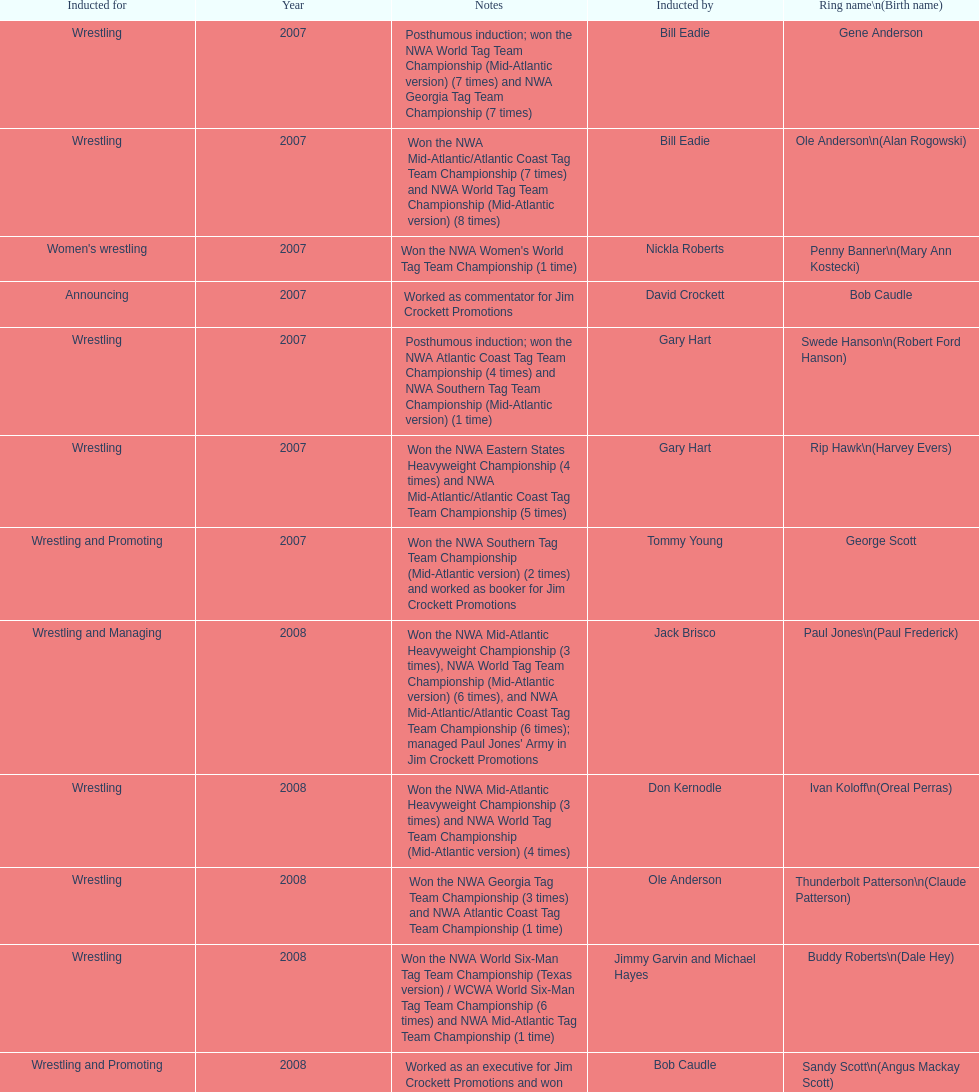How many members were inducted for announcing? 2. Write the full table. {'header': ['Inducted for', 'Year', 'Notes', 'Inducted by', 'Ring name\\n(Birth name)'], 'rows': [['Wrestling', '2007', 'Posthumous induction; won the NWA World Tag Team Championship (Mid-Atlantic version) (7 times) and NWA Georgia Tag Team Championship (7 times)', 'Bill Eadie', 'Gene Anderson'], ['Wrestling', '2007', 'Won the NWA Mid-Atlantic/Atlantic Coast Tag Team Championship (7 times) and NWA World Tag Team Championship (Mid-Atlantic version) (8 times)', 'Bill Eadie', 'Ole Anderson\\n(Alan Rogowski)'], ["Women's wrestling", '2007', "Won the NWA Women's World Tag Team Championship (1 time)", 'Nickla Roberts', 'Penny Banner\\n(Mary Ann Kostecki)'], ['Announcing', '2007', 'Worked as commentator for Jim Crockett Promotions', 'David Crockett', 'Bob Caudle'], ['Wrestling', '2007', 'Posthumous induction; won the NWA Atlantic Coast Tag Team Championship (4 times) and NWA Southern Tag Team Championship (Mid-Atlantic version) (1 time)', 'Gary Hart', 'Swede Hanson\\n(Robert Ford Hanson)'], ['Wrestling', '2007', 'Won the NWA Eastern States Heavyweight Championship (4 times) and NWA Mid-Atlantic/Atlantic Coast Tag Team Championship (5 times)', 'Gary Hart', 'Rip Hawk\\n(Harvey Evers)'], ['Wrestling and Promoting', '2007', 'Won the NWA Southern Tag Team Championship (Mid-Atlantic version) (2 times) and worked as booker for Jim Crockett Promotions', 'Tommy Young', 'George Scott'], ['Wrestling and Managing', '2008', "Won the NWA Mid-Atlantic Heavyweight Championship (3 times), NWA World Tag Team Championship (Mid-Atlantic version) (6 times), and NWA Mid-Atlantic/Atlantic Coast Tag Team Championship (6 times); managed Paul Jones' Army in Jim Crockett Promotions", 'Jack Brisco', 'Paul Jones\\n(Paul Frederick)'], ['Wrestling', '2008', 'Won the NWA Mid-Atlantic Heavyweight Championship (3 times) and NWA World Tag Team Championship (Mid-Atlantic version) (4 times)', 'Don Kernodle', 'Ivan Koloff\\n(Oreal Perras)'], ['Wrestling', '2008', 'Won the NWA Georgia Tag Team Championship (3 times) and NWA Atlantic Coast Tag Team Championship (1 time)', 'Ole Anderson', 'Thunderbolt Patterson\\n(Claude Patterson)'], ['Wrestling', '2008', 'Won the NWA World Six-Man Tag Team Championship (Texas version) / WCWA World Six-Man Tag Team Championship (6 times) and NWA Mid-Atlantic Tag Team Championship (1 time)', 'Jimmy Garvin and Michael Hayes', 'Buddy Roberts\\n(Dale Hey)'], ['Wrestling and Promoting', '2008', 'Worked as an executive for Jim Crockett Promotions and won the NWA World Tag Team Championship (Central States version) (1 time) and NWA Southern Tag Team Championship (Mid-Atlantic version) (3 times)', 'Bob Caudle', 'Sandy Scott\\n(Angus Mackay Scott)'], ['Wrestling', '2008', 'Won the NWA United States Tag Team Championship (Tri-State version) (2 times) and NWA Texas Heavyweight Championship (1 time)', 'Magnum T.A.', 'Grizzly Smith\\n(Aurelian Smith)'], ['Wrestling', '2008', 'Posthumous induction; won the NWA Atlantic Coast/Mid-Atlantic Tag Team Championship (8 times) and NWA Southern Tag Team Championship (Mid-Atlantic version) (6 times)', 'Rip Hawk', 'Johnny Weaver\\n(Kenneth Eugene Weaver)'], ['Wrestling', '2009', 'Won the NWA Southern Tag Team Championship (Mid-America version) (2 times) and NWA World Tag Team Championship (Mid-America version) (6 times)', 'Jerry Jarrett & Steve Keirn', 'Don Fargo\\n(Don Kalt)'], ['Wrestling', '2009', 'Won the NWA World Tag Team Championship (Mid-America version) (10 times) and NWA Southern Tag Team Championship (Mid-America version) (22 times)', 'Jerry Jarrett & Steve Keirn', 'Jackie Fargo\\n(Henry Faggart)'], ['Wrestling', '2009', 'Posthumous induction; won the NWA Southern Tag Team Championship (Mid-America version) (3 times)', 'Jerry Jarrett & Steve Keirn', 'Sonny Fargo\\n(Jack Lewis Faggart)'], ['Managing and Promoting', '2009', 'Posthumous induction; worked as a booker in World Class Championship Wrestling and managed several wrestlers in Mid-Atlantic Championship Wrestling', 'Sir Oliver Humperdink', 'Gary Hart\\n(Gary Williams)'], ['Wrestling', '2009', 'Posthumous induction; won the NWA Mid-Atlantic Heavyweight Championship (6 times) and NWA World Tag Team Championship (Mid-Atlantic version) (4 times)', 'Tully Blanchard', 'Wahoo McDaniel\\n(Edward McDaniel)'], ['Wrestling', '2009', 'Won the NWA Texas Heavyweight Championship (1 time) and NWA World Tag Team Championship (Mid-Atlantic version) (1 time)', 'Ric Flair', 'Blackjack Mulligan\\n(Robert Windham)'], ['Wrestling', '2009', 'Won the NWA Atlantic Coast Tag Team Championship (2 times)', 'Brad Anderson, Tommy Angel & David Isley', 'Nelson Royal'], ['Announcing', '2009', 'Worked as commentator for wrestling events in the Memphis area', 'Dave Brown', 'Lance Russell']]} 